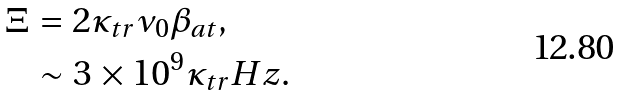<formula> <loc_0><loc_0><loc_500><loc_500>\Xi & = 2 \kappa _ { t r } \nu _ { 0 } \beta _ { a t } , \\ & \sim 3 \times 1 0 ^ { 9 } \kappa _ { t r } H z .</formula> 